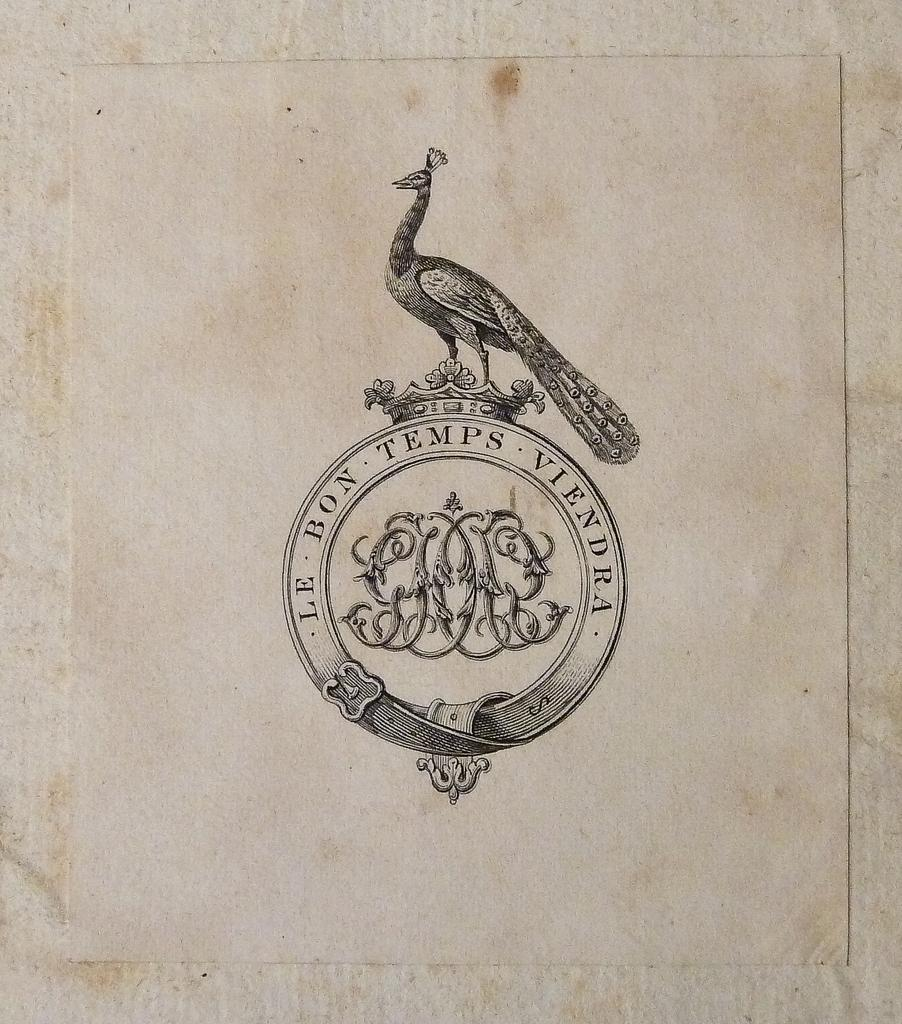What is the main feature of the image? There is a logo in the image. What else can be seen in the image besides the logo? There is text written in the image. What color is the background of the image? The background of the image is white. What type of lumber is being used to build the structure in the image? There is no structure or lumber present in the image; it only contains a logo and text on a white background. 